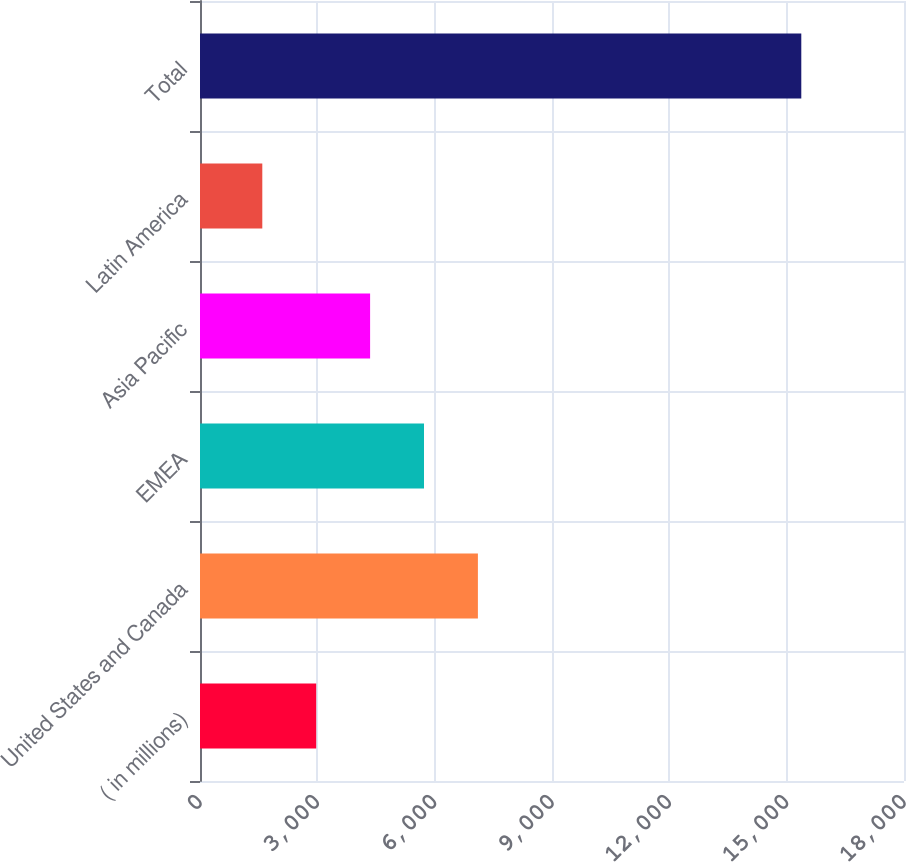<chart> <loc_0><loc_0><loc_500><loc_500><bar_chart><fcel>( in millions)<fcel>United States and Canada<fcel>EMEA<fcel>Asia Pacific<fcel>Latin America<fcel>Total<nl><fcel>2971.1<fcel>7105.4<fcel>5727.3<fcel>4349.2<fcel>1593<fcel>15374<nl></chart> 